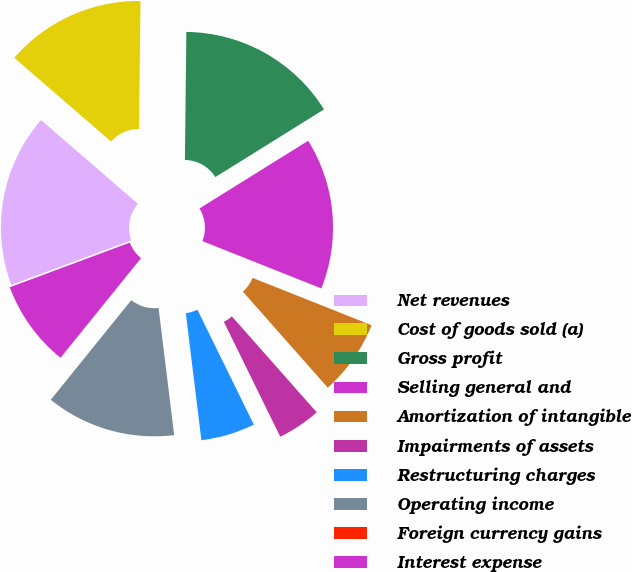Convert chart to OTSL. <chart><loc_0><loc_0><loc_500><loc_500><pie_chart><fcel>Net revenues<fcel>Cost of goods sold (a)<fcel>Gross profit<fcel>Selling general and<fcel>Amortization of intangible<fcel>Impairments of assets<fcel>Restructuring charges<fcel>Operating income<fcel>Foreign currency gains<fcel>Interest expense<nl><fcel>17.02%<fcel>13.83%<fcel>15.95%<fcel>14.89%<fcel>7.45%<fcel>4.26%<fcel>5.32%<fcel>12.76%<fcel>0.0%<fcel>8.51%<nl></chart> 